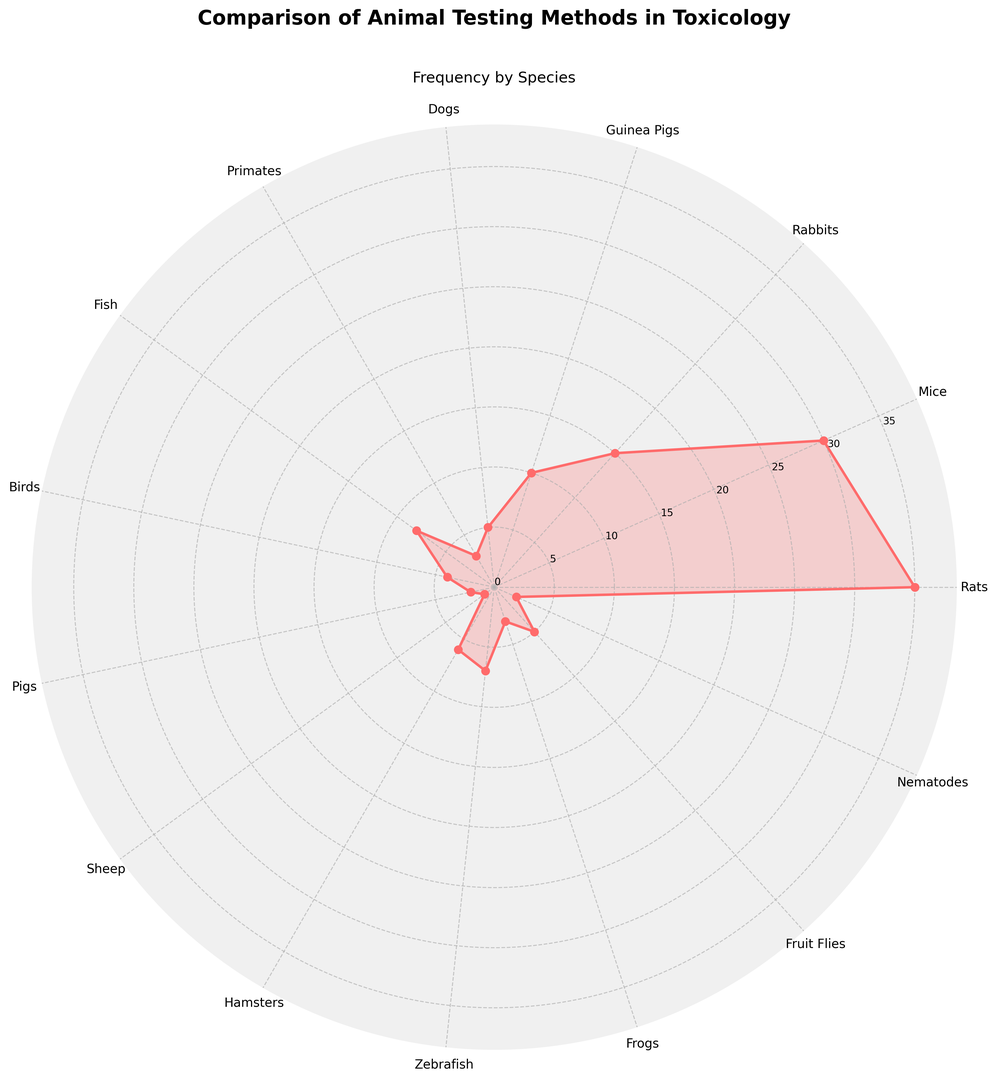Which species is tested the least frequently? The species with the smallest height in the rose chart represents the least frequently tested species. In this case, it is Sheep.
Answer: Sheep What is the total frequency of testing for Guinea Pigs and Zebrafish combined? The frequencies for Guinea Pigs and Zebrafish are 10 and 7 respectively. Adding these together gives 10 + 7 = 17.
Answer: 17 Which species has a higher frequency of testing, Dogs or Primates? By comparing the lengths of the respective segments on the chart, Dogs have a frequency of 5 and Primates have a frequency of 3. Dogs have a higher frequency.
Answer: Dogs Arrange the species in descending order based on their frequency of testing. By visually observing and arranging the heights of the segments, the order from highest to lowest is: Rats, Mice, Rabbits, Guinea Pigs, Fish, Zebrafish, Hamsters, Dogs, Fruit Flies, Birds, Primates, Frogs, Nematodes, Pigs, Sheep.
Answer: Rats, Mice, Rabbits, Guinea Pigs, Fish, Zebrafish, Hamsters, Dogs, Fruit Flies, Birds, Primates, Frogs, Nematodes, Pigs, Sheep What is the difference in testing frequency between Mice and Birds? The frequency for Mice is 30 while for Birds it is 4. The difference is 30 - 4 = 26.
Answer: 26 Identify the species that have a testing frequency greater than 10. Checking each segment’s length in the rose chart, the species with frequencies greater than 10 are Rats, Mice, and Rabbits.
Answer: Rats, Mice, Rabbits Which species are tested exactly twice as frequently as Fruit Flies? Fruit Flies have a testing frequency of 5, and twice this value is 10. The species with a frequency of 10 is Guinea Pigs.
Answer: Guinea Pigs How much higher is the frequency of testing for Rats compared to Fish? The frequency for Rats is 35, whereas for Fish, it is 8. The difference is 35 - 8 = 27.
Answer: 27 What is the average frequency of testing for Dogs, Primates, and Fish combined? The frequencies for Dogs, Primates, and Fish are 5, 3, and 8 respectively. Adding these gives 5 + 3 + 8 = 16. Dividing by the number of species, (16/3) ≈ 5.33.
Answer: 5.33 